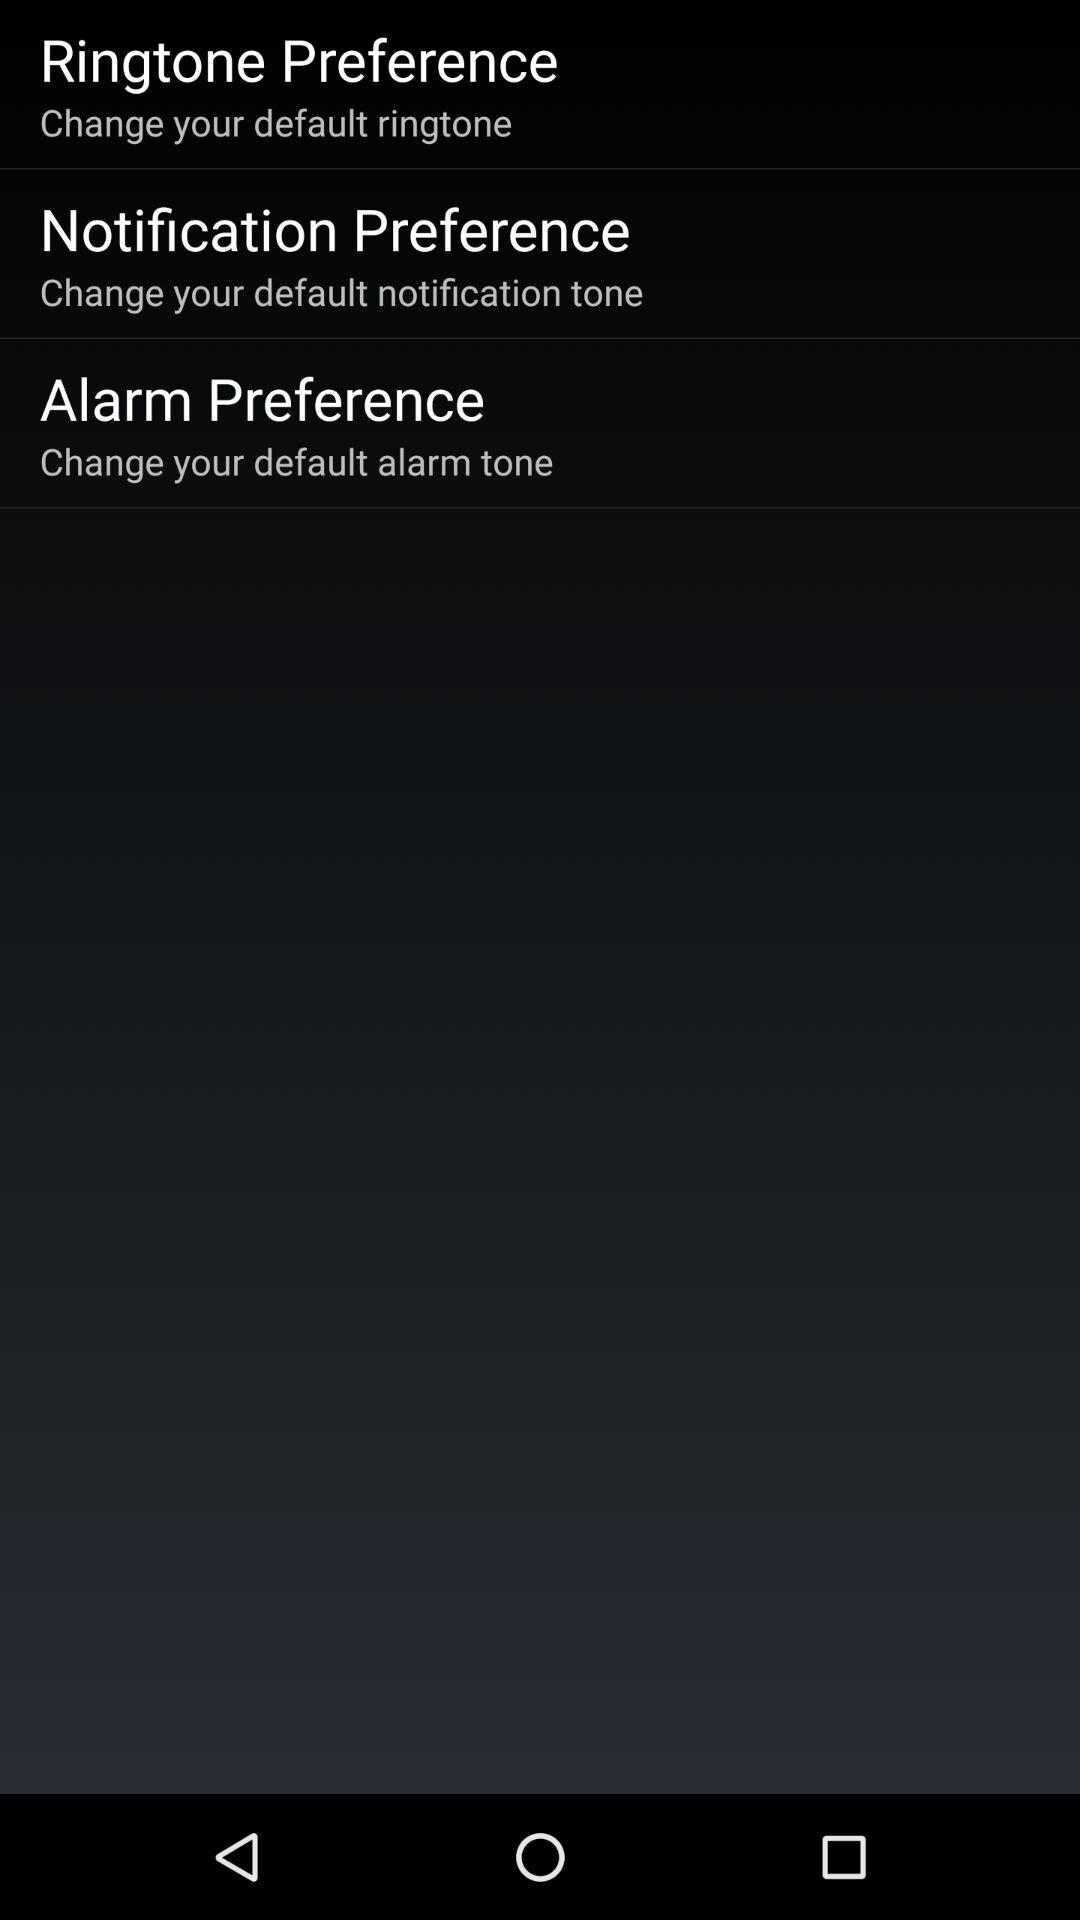How many preferences are there in this screen?
Answer the question using a single word or phrase. 3 